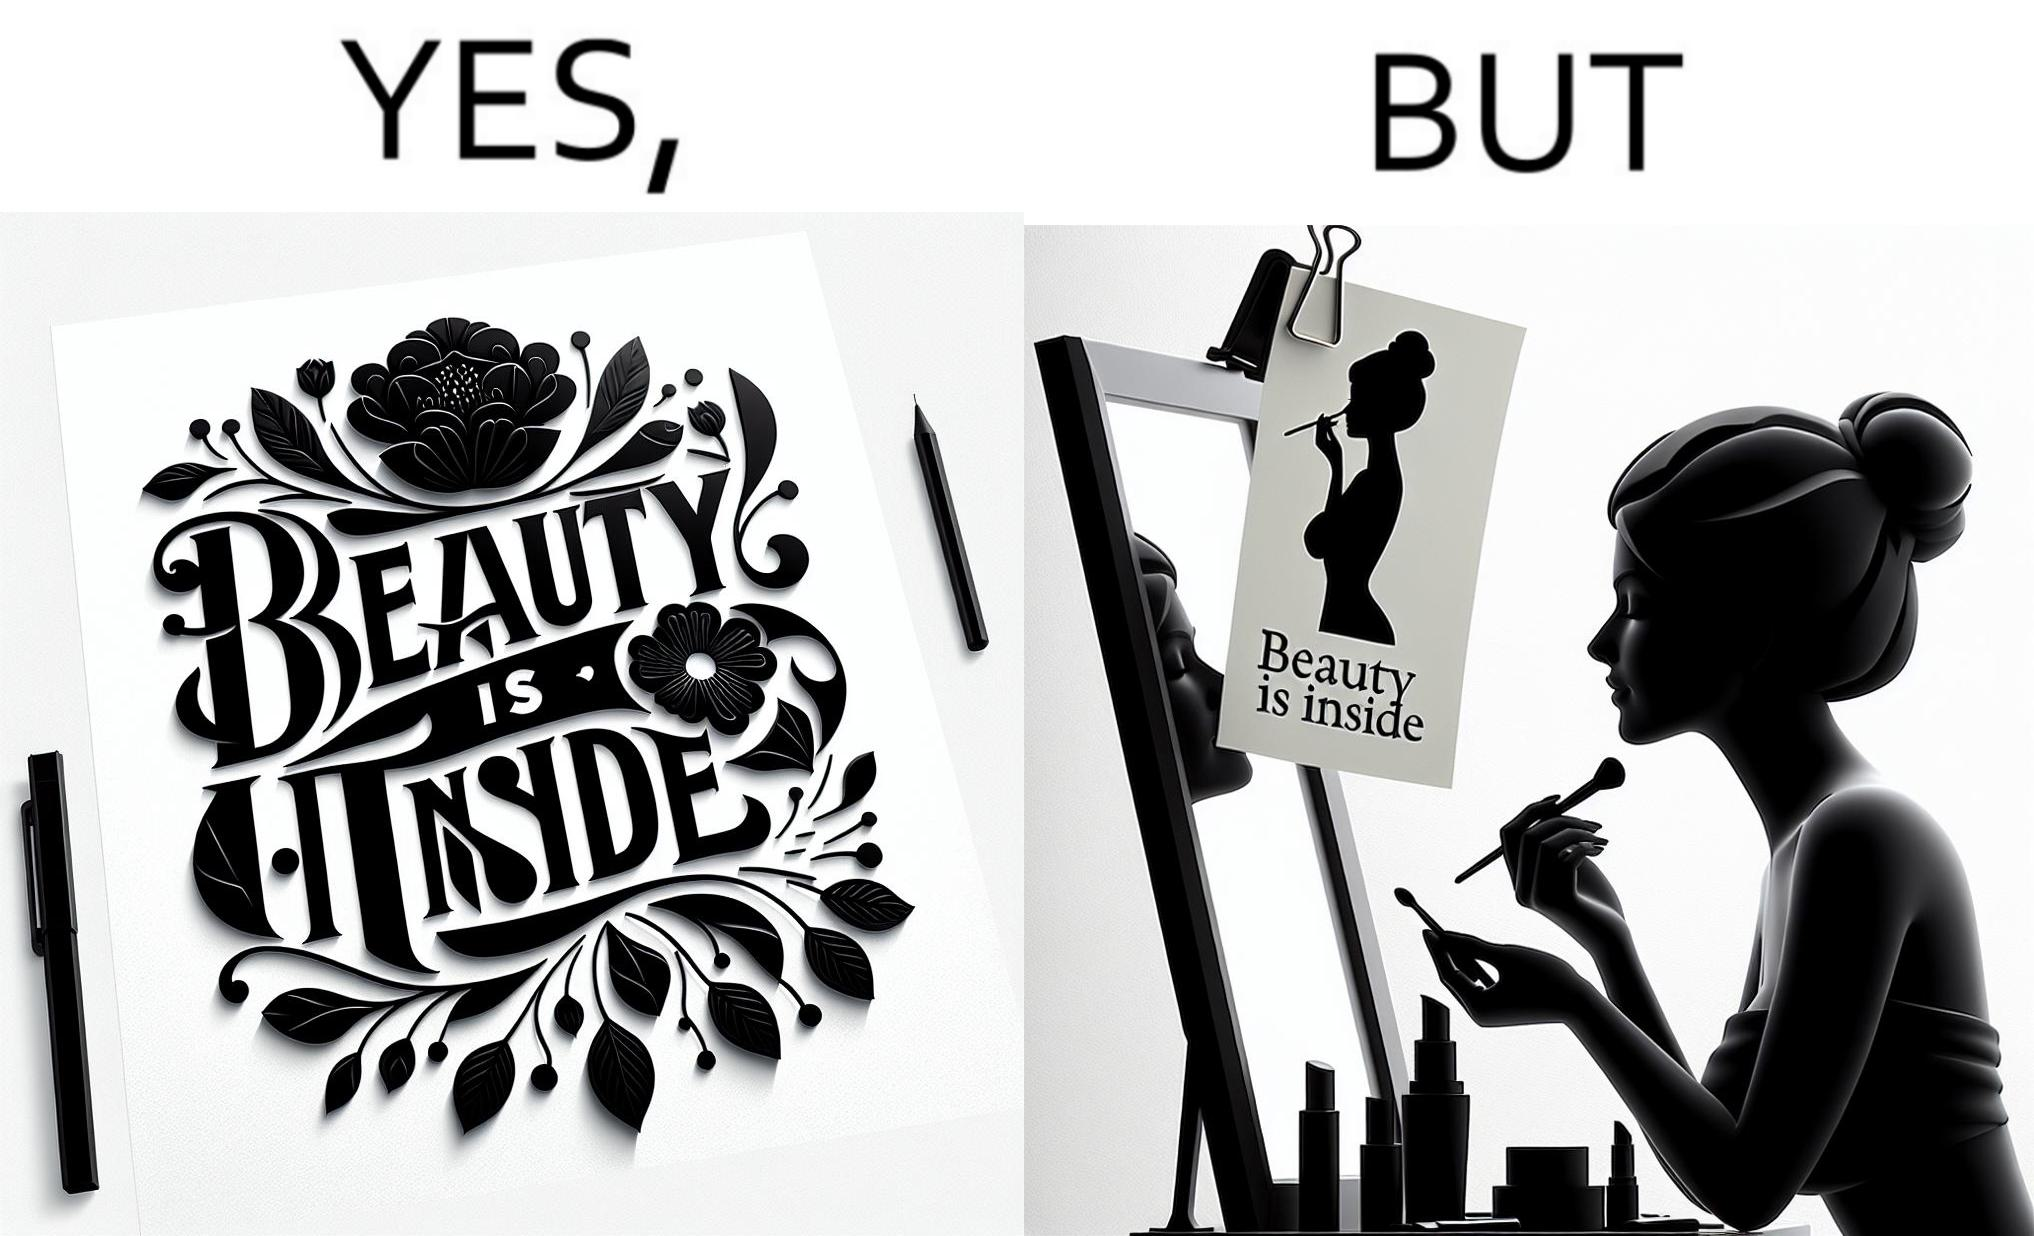What is shown in the left half versus the right half of this image? In the left part of the image: The image shows a text in beautiful font with flowers drawn around it. The text says "Beauty Is Inside". In the right part of the image: The image shows a woman applying makeup after shower by looking at herself in the dressing mirror. A piece of paper that says "Beauty is Inside" is clipped to the top of the mirror. 